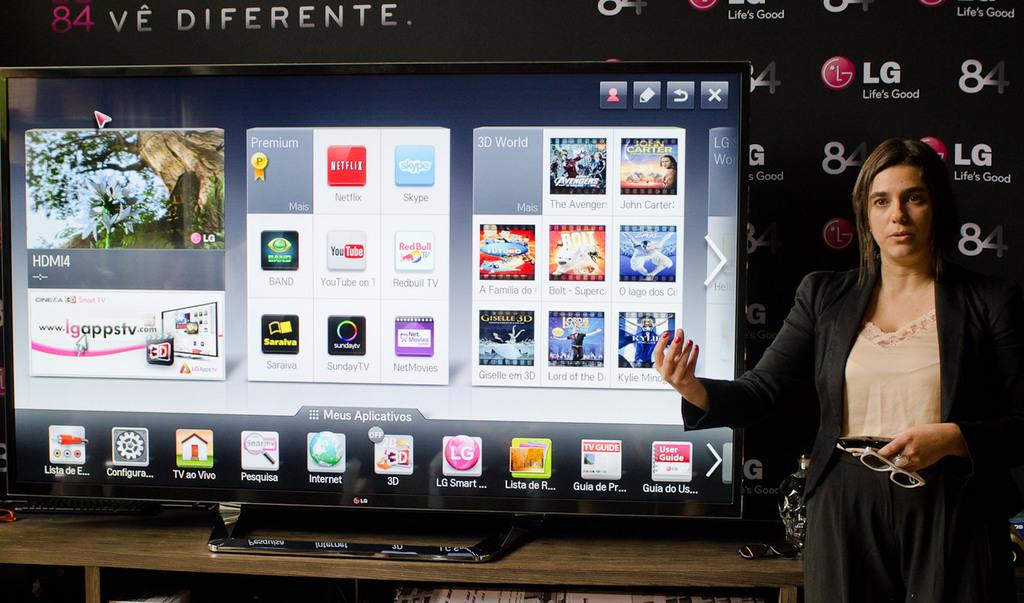Is that a netflix app?
Give a very brief answer. Yes. 